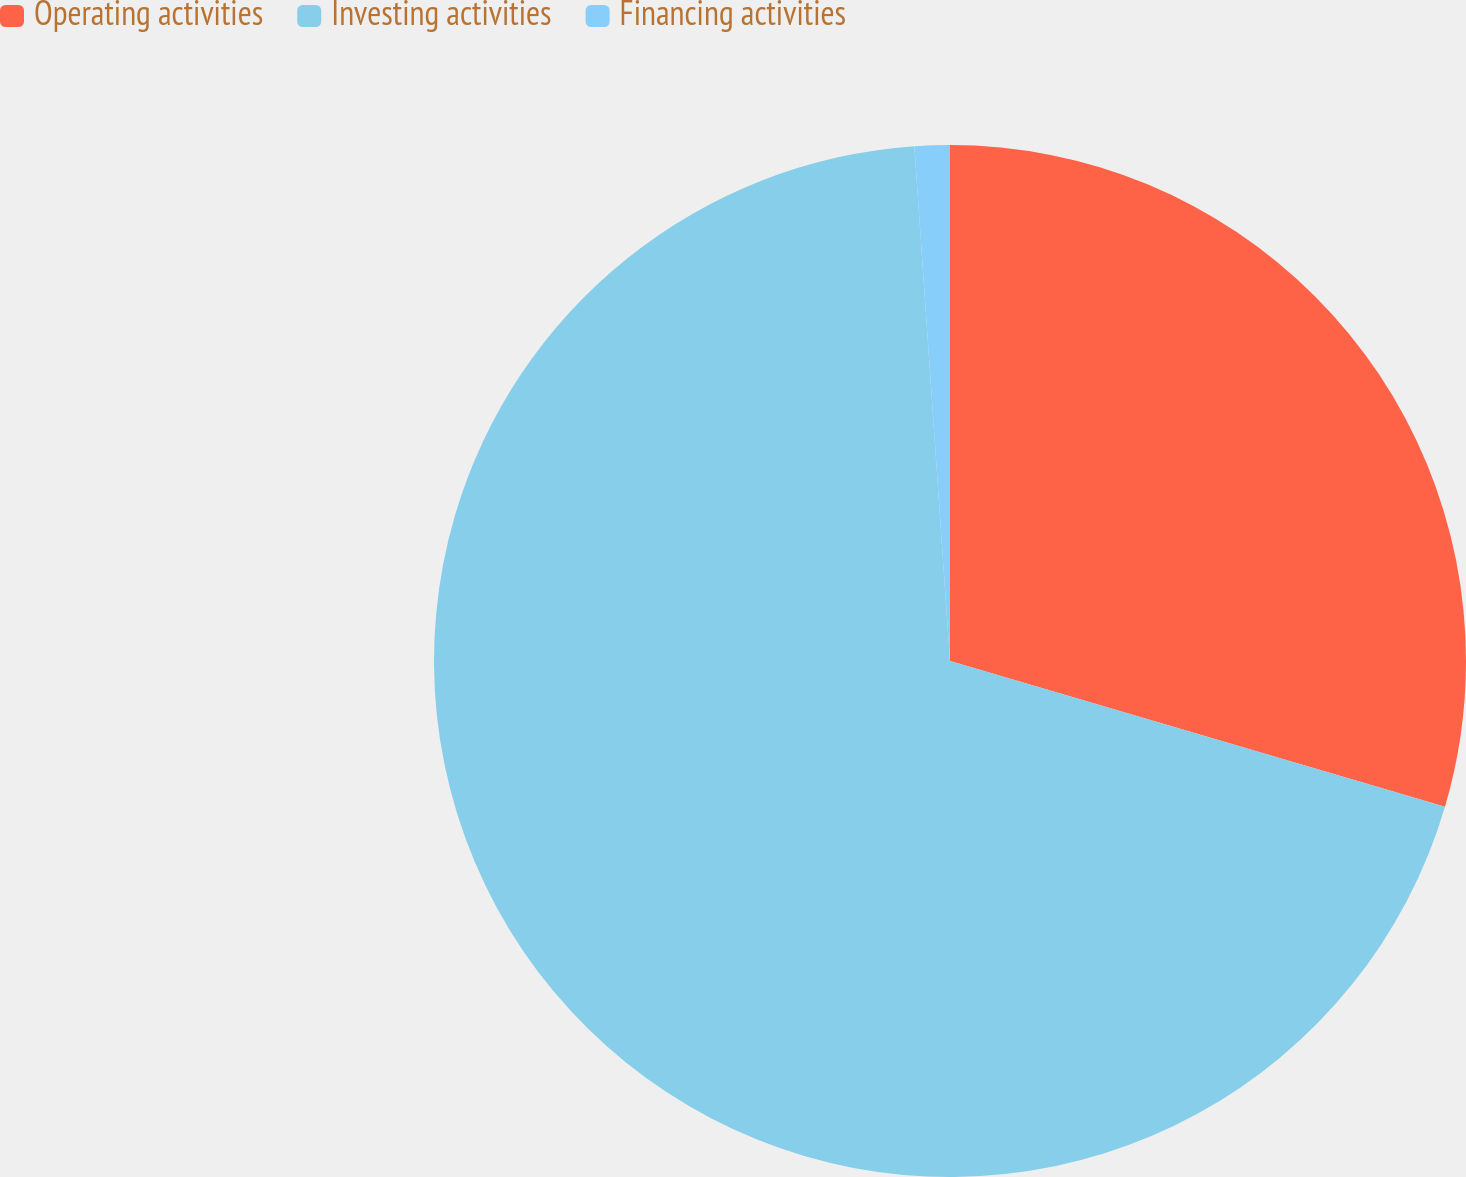<chart> <loc_0><loc_0><loc_500><loc_500><pie_chart><fcel>Operating activities<fcel>Investing activities<fcel>Financing activities<nl><fcel>29.56%<fcel>69.35%<fcel>1.1%<nl></chart> 